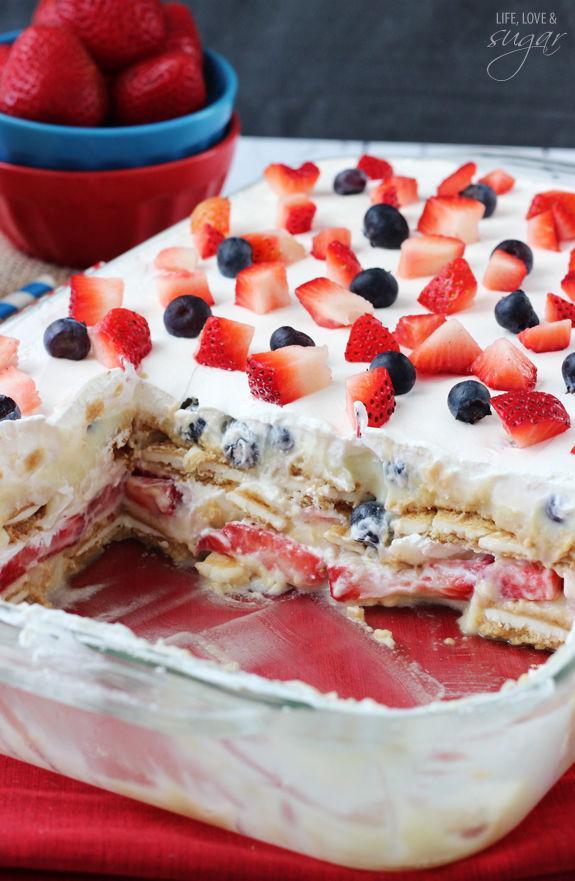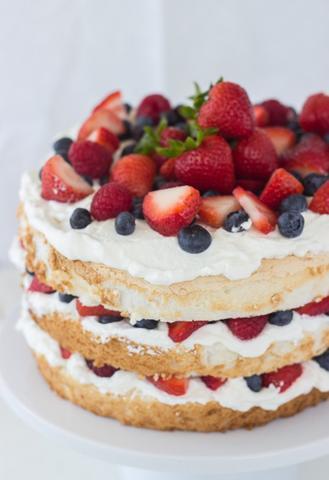The first image is the image on the left, the second image is the image on the right. For the images displayed, is the sentence "There is an eating utensil next to a bowl of dessert." factually correct? Answer yes or no. No. The first image is the image on the left, the second image is the image on the right. Given the left and right images, does the statement "A dessert is garnished with blueberries, strawberry slices, and a few strawberries with their leafy green caps intact." hold true? Answer yes or no. Yes. 